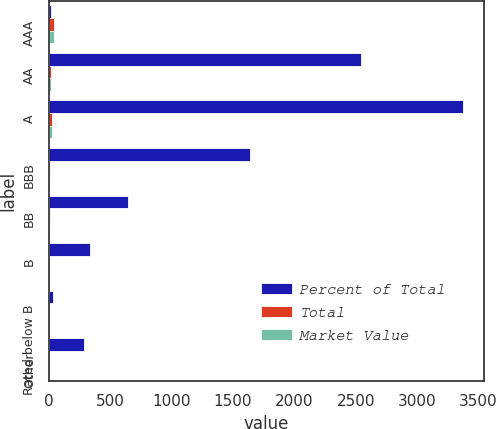Convert chart. <chart><loc_0><loc_0><loc_500><loc_500><stacked_bar_chart><ecel><fcel>AAA<fcel>AA<fcel>A<fcel>BBB<fcel>BB<fcel>B<fcel>Rated below B<fcel>Other<nl><fcel>Percent of Total<fcel>18.4<fcel>2544.9<fcel>3374<fcel>1637<fcel>640<fcel>333.3<fcel>29.9<fcel>288.6<nl><fcel>Total<fcel>40<fcel>17.2<fcel>22.9<fcel>11.1<fcel>4.3<fcel>2.3<fcel>0.2<fcel>2<nl><fcel>Market Value<fcel>40.6<fcel>18.4<fcel>20.3<fcel>10.8<fcel>5.7<fcel>2.9<fcel>0.3<fcel>1<nl></chart> 